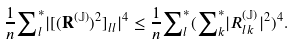Convert formula to latex. <formula><loc_0><loc_0><loc_500><loc_500>\frac { 1 } { n } { \sum } ^ { * } _ { l } | [ ( \mathbf R ^ { ( \mathbb { J } ) } ) ^ { 2 } ] _ { l l } | ^ { 4 } \leq \frac { 1 } { n } { \sum } ^ { * } _ { l } ( { \sum } ^ { * } _ { k } | R ^ { ( \mathbb { J } ) } _ { l k } | ^ { 2 } ) ^ { 4 } .</formula> 